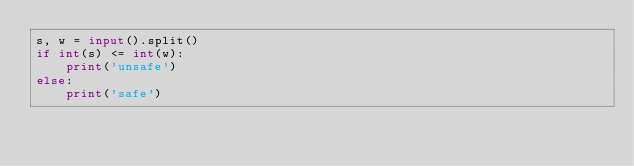Convert code to text. <code><loc_0><loc_0><loc_500><loc_500><_Python_>s, w = input().split()
if int(s) <= int(w):
    print('unsafe')
else:
    print('safe')</code> 